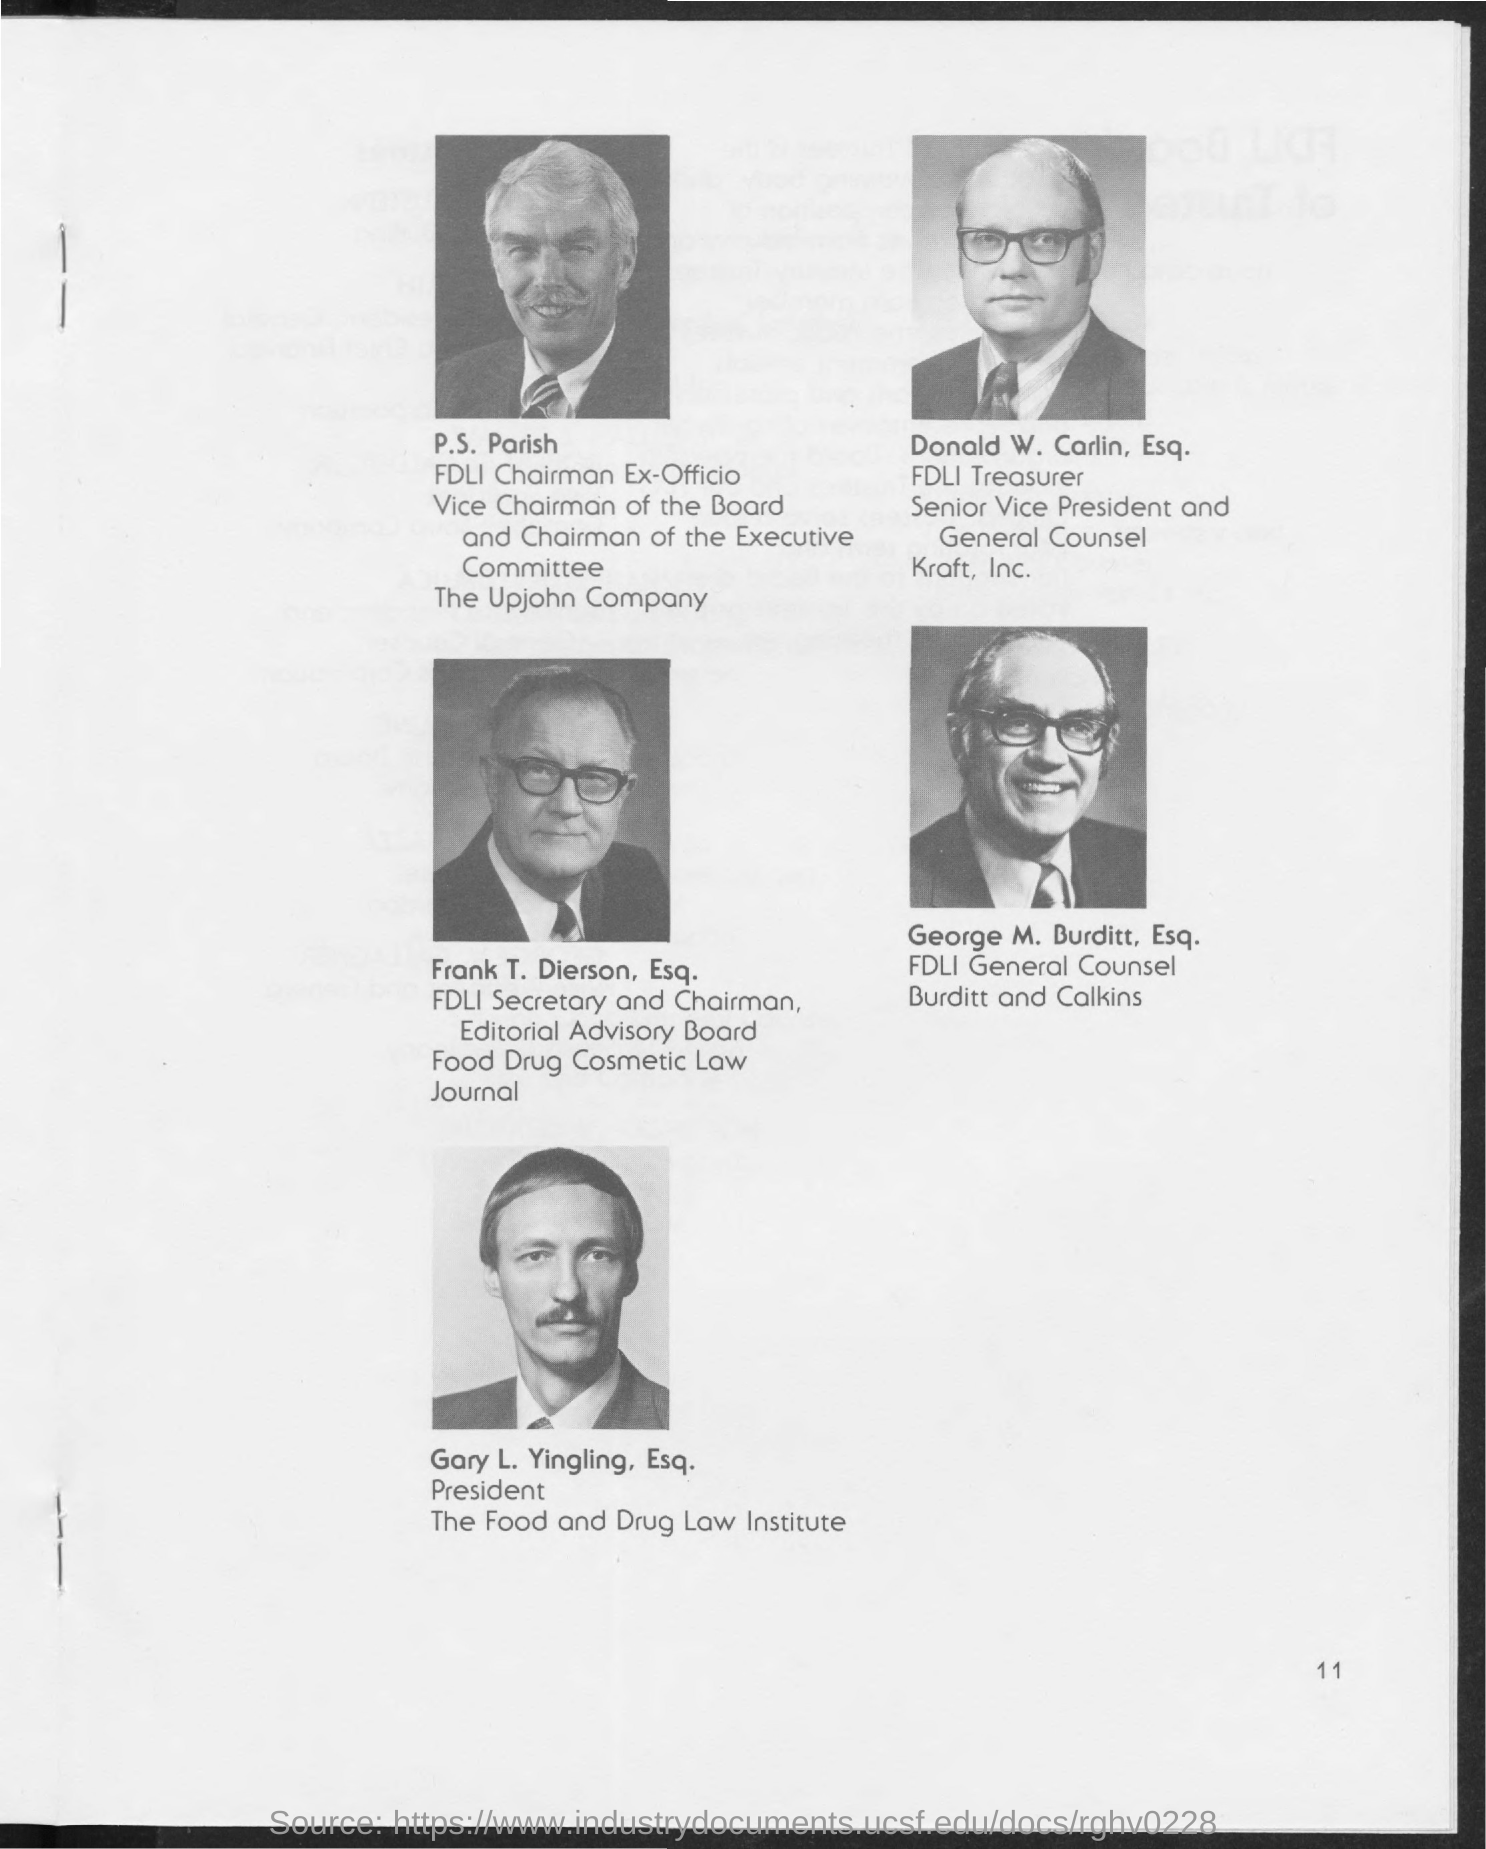Specify some key components in this picture. Frank T. Dierson, Esq. is the Secretary and Chairman of the FDLI (Food and Drug Law Institute). The FDLI general counsel is named Burditt and Calkins. The name of the general counsel is George M. Burditt, Esq.. The FDLI treasurer is Donald W. Carlin, Esq. P.S. Parish is the chairman of the FDLI (Food and Drug Law Institute) and is serving in an Ex-Officio capacity. 